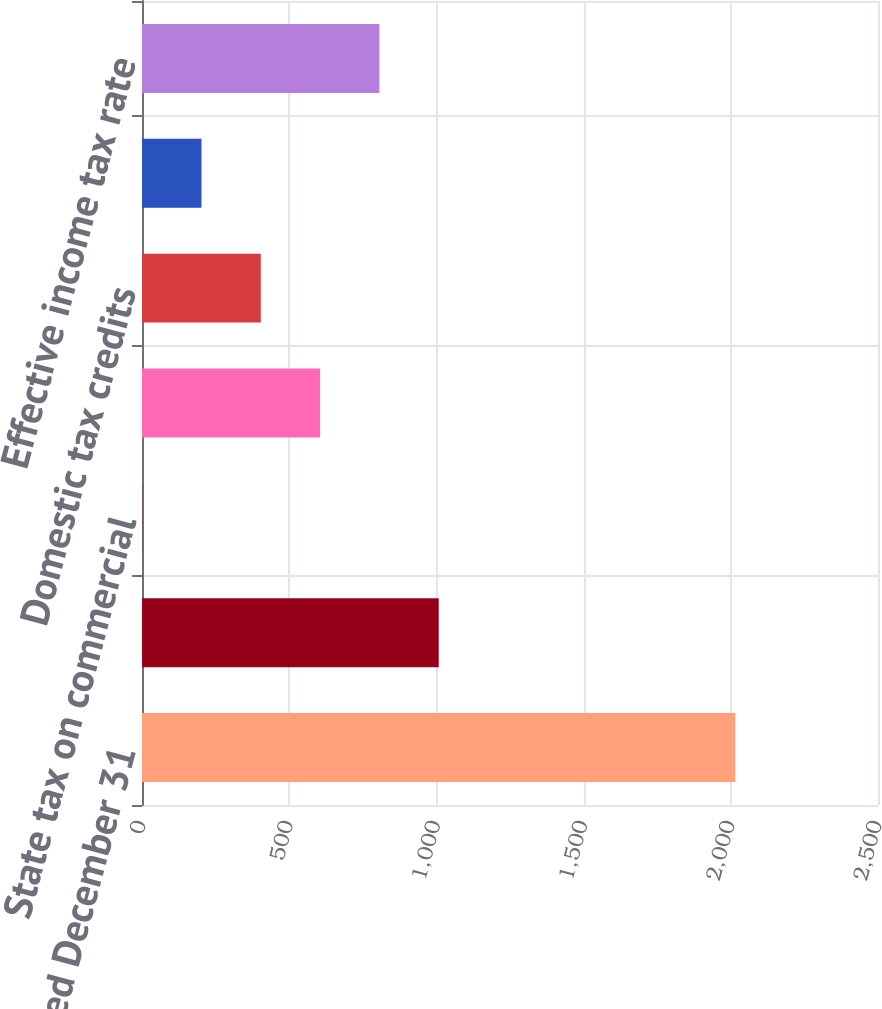<chart> <loc_0><loc_0><loc_500><loc_500><bar_chart><fcel>Year Ended December 31<fcel>Statutory federal income tax<fcel>State tax on commercial<fcel>Domestic production deduction<fcel>Domestic tax credits<fcel>Other net<fcel>Effective income tax rate<nl><fcel>2015<fcel>1007.8<fcel>0.6<fcel>604.92<fcel>403.48<fcel>202.04<fcel>806.36<nl></chart> 